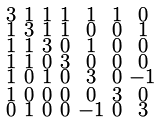Convert formula to latex. <formula><loc_0><loc_0><loc_500><loc_500>\begin{smallmatrix} 3 & 1 & 1 & 1 & 1 & 1 & 0 \\ 1 & 3 & 1 & 1 & 0 & 0 & 1 \\ 1 & 1 & 3 & 0 & 1 & 0 & 0 \\ 1 & 1 & 0 & 3 & 0 & 0 & 0 \\ 1 & 0 & 1 & 0 & 3 & 0 & - 1 \\ 1 & 0 & 0 & 0 & 0 & 3 & 0 \\ 0 & 1 & 0 & 0 & - 1 & 0 & 3 \end{smallmatrix}</formula> 